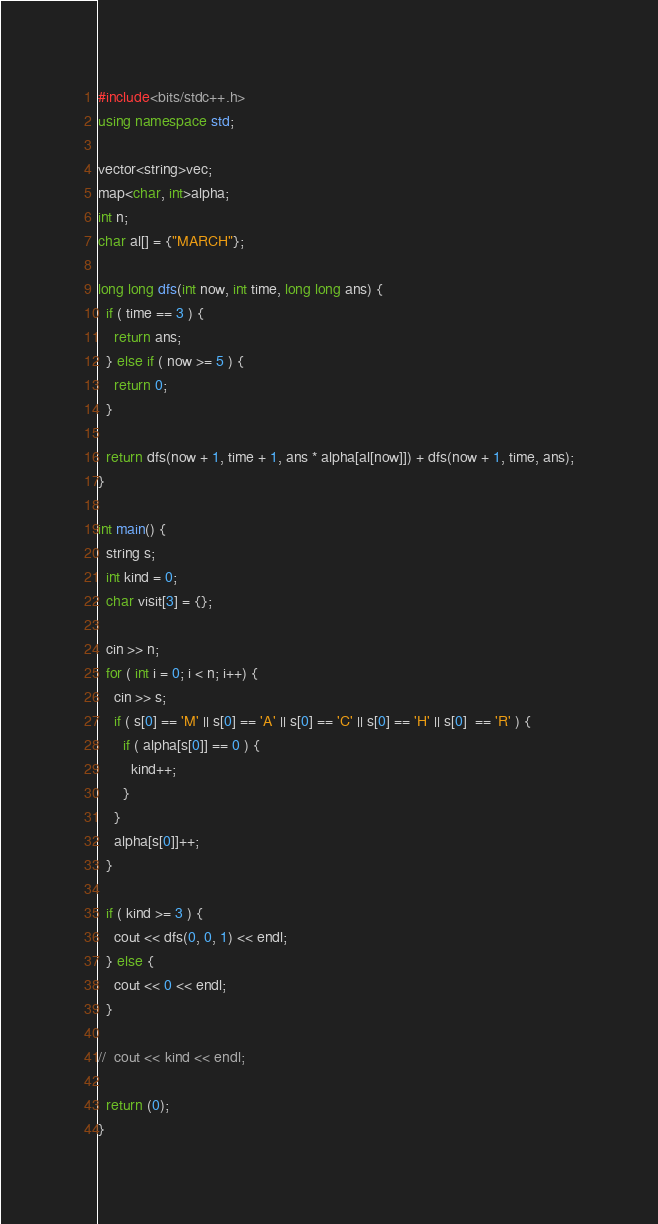<code> <loc_0><loc_0><loc_500><loc_500><_C++_>#include<bits/stdc++.h>
using namespace std;

vector<string>vec;
map<char, int>alpha;
int n;
char al[] = {"MARCH"};

long long dfs(int now, int time, long long ans) {
  if ( time == 3 ) {
    return ans;
  } else if ( now >= 5 ) {
    return 0;
  }

  return dfs(now + 1, time + 1, ans * alpha[al[now]]) + dfs(now + 1, time, ans);
}

int main() {
  string s;
  int kind = 0;
  char visit[3] = {};
  
  cin >> n;
  for ( int i = 0; i < n; i++) {
    cin >> s;
    if ( s[0] == 'M' || s[0] == 'A' || s[0] == 'C' || s[0] == 'H' || s[0]  == 'R' ) {
      if ( alpha[s[0]] == 0 ) {
        kind++;
      }
    }
    alpha[s[0]]++;
  }

  if ( kind >= 3 ) {
    cout << dfs(0, 0, 1) << endl;
  } else {
    cout << 0 << endl;
  }

//  cout << kind << endl;

  return (0);
}</code> 